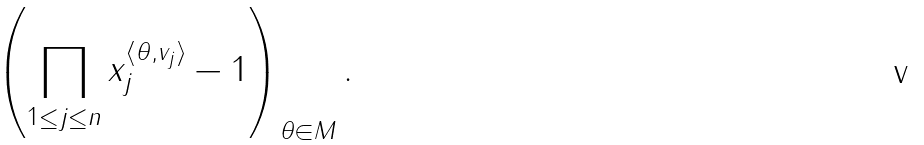Convert formula to latex. <formula><loc_0><loc_0><loc_500><loc_500>\left ( \prod _ { 1 \leq j \leq n } x _ { j } ^ { \langle \theta , v _ { j } \rangle } - 1 \right ) _ { \theta \in M } .</formula> 